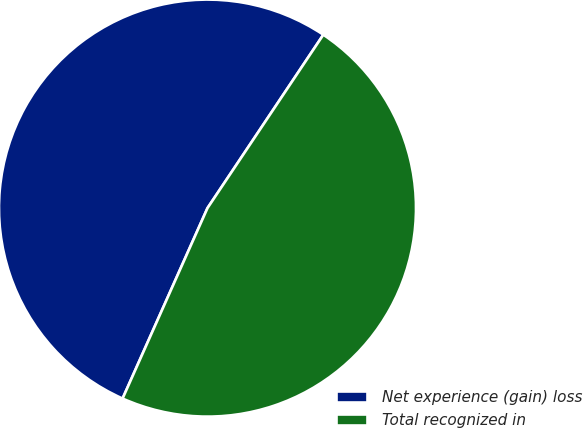Convert chart. <chart><loc_0><loc_0><loc_500><loc_500><pie_chart><fcel>Net experience (gain) loss<fcel>Total recognized in<nl><fcel>52.7%<fcel>47.3%<nl></chart> 